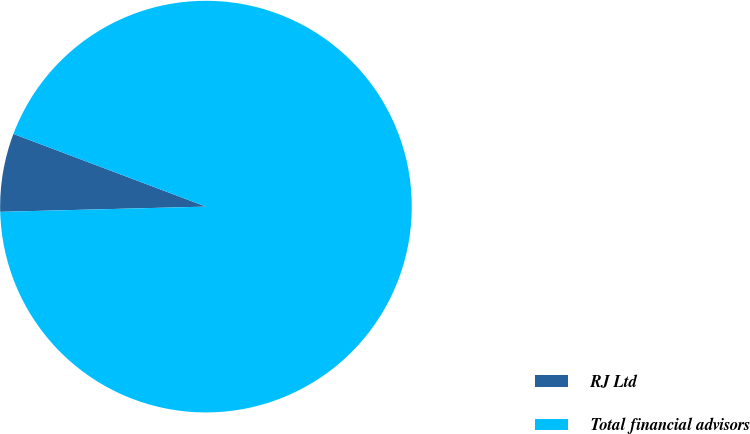<chart> <loc_0><loc_0><loc_500><loc_500><pie_chart><fcel>RJ Ltd<fcel>Total financial advisors<nl><fcel>6.15%<fcel>93.85%<nl></chart> 